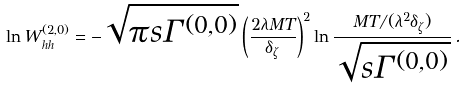Convert formula to latex. <formula><loc_0><loc_0><loc_500><loc_500>\ln { W } ^ { ( 2 , 0 ) } _ { h h } = - \sqrt { \pi { s } \Gamma ^ { ( 0 , 0 ) } } \left ( \frac { 2 \lambda { M } T } { \delta _ { \zeta } } \right ) ^ { 2 } \ln \frac { M T / ( \lambda ^ { 2 } \delta _ { \zeta } ) } { \sqrt { { s } \Gamma ^ { ( 0 , 0 ) } } } \, .</formula> 